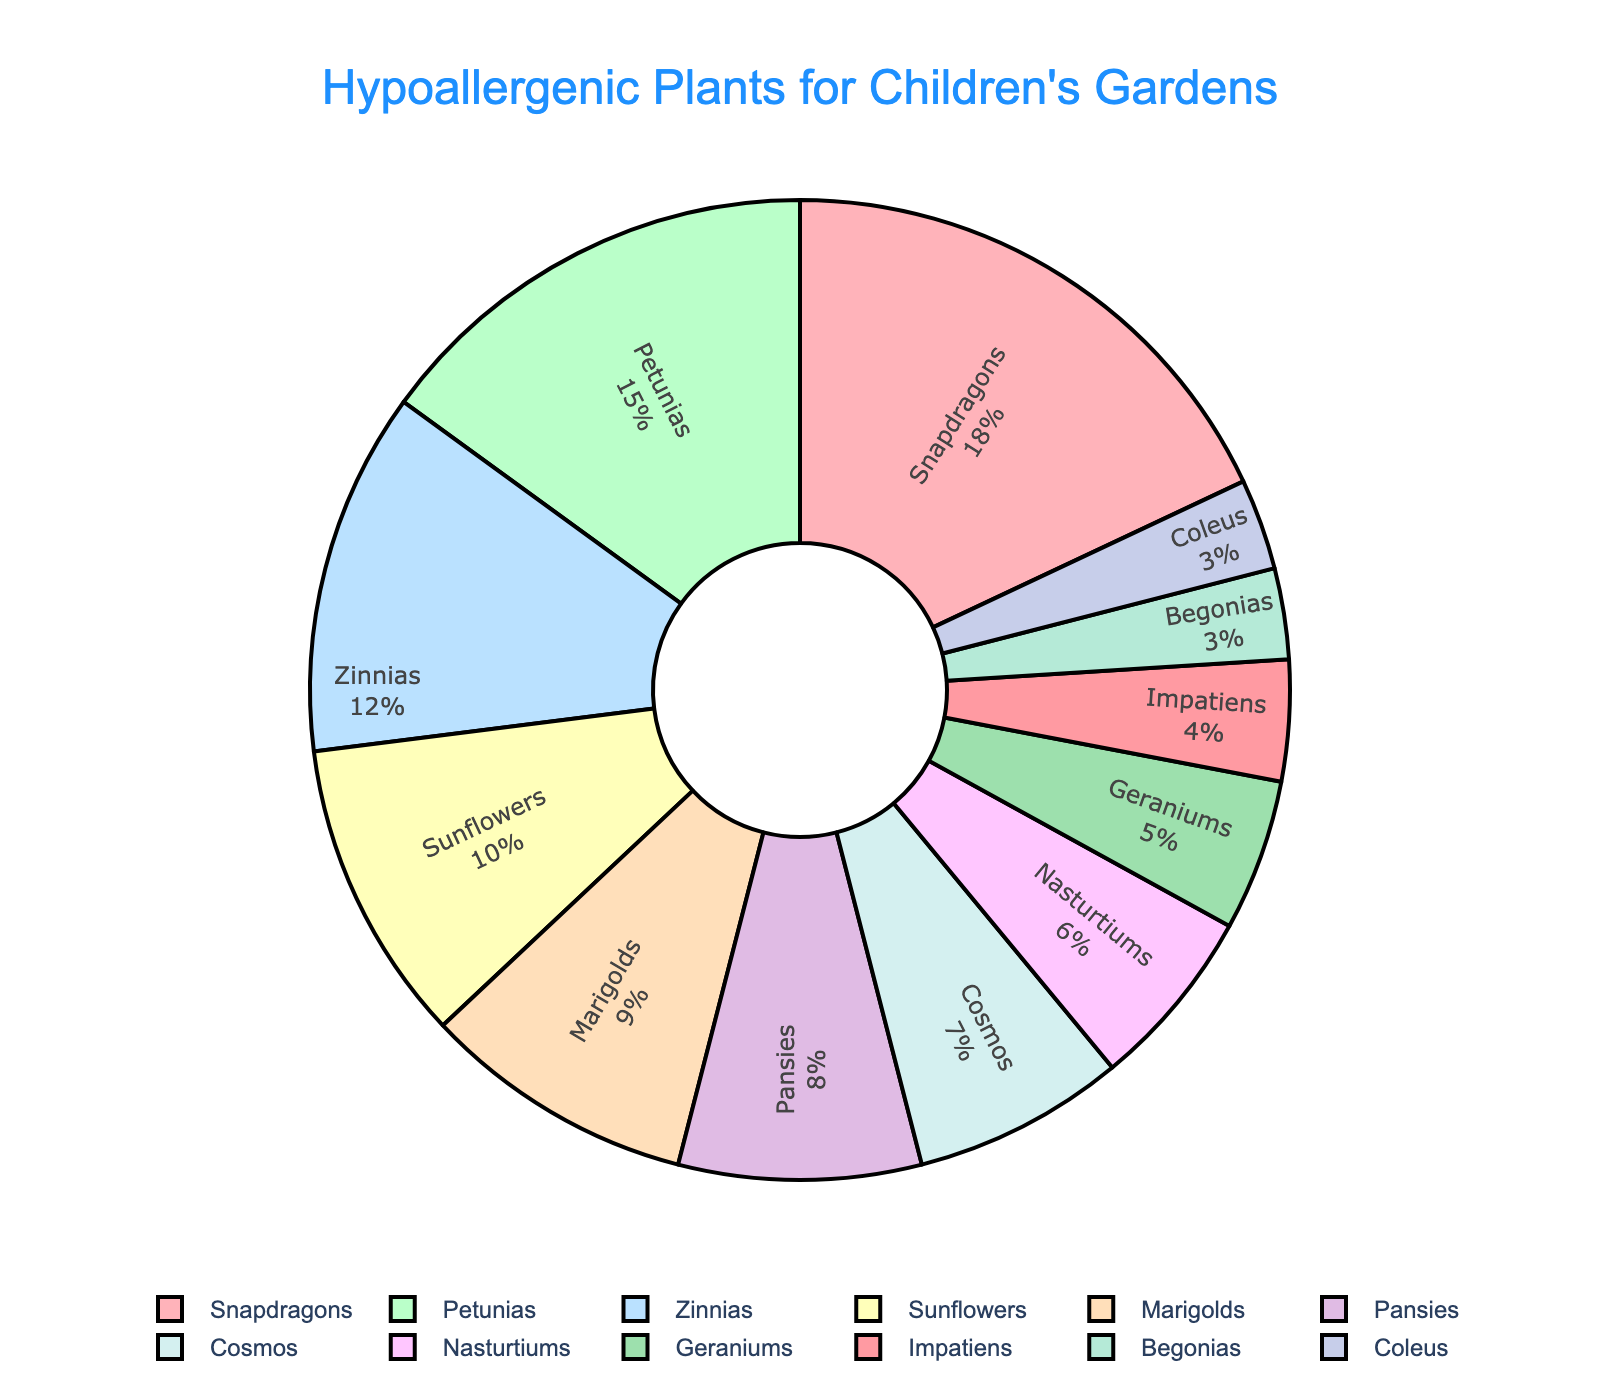What's the most common hypoallergenic plant in children's gardens? The most common plant is the one with the largest percentage slice in the pie chart. Snapdragons have the largest percentage slice, which is 18%.
Answer: Snapdragons What is the combined percentage of Zinnias and Sunflowers? Add the percentage values of Zinnias (12%) and Sunflowers (10%). Thus, the combined percentage is 12% + 10% = 22%.
Answer: 22% Which plant type is less common: Geraniums or Impatiens? Compare the percentage values: Geraniums (5%) and Impatiens (4%). Since 4% is less than 5%, Impatiens is less common.
Answer: Impatiens What is the total percentage of plants that have a percentage of 8% or higher? Sum the percentages of plants that are 8% or higher: Snapdragons (18%), Petunias (15%), Zinnias (12%), and Sunflowers (10%) and Pansies (8%). 18% + 15% + 12% + 10% + 8% = 63%.
Answer: 63% Which plant types have the smallest representation, and what is their combined percentage? Identify the plant types with the smallest percentages: Begonias (3%) and Coleus (3%). Add their percentages together: 3% + 3% = 6%.
Answer: Begonias and Coleus, 6% What is the visual color of the section for Marigolds? Marigolds are represented with a specific color in the pie chart to distinguish them visually. They are shown in orange.
Answer: Orange Are there more Nasturtiums or Cosmos in the garden, and by how much? Compare their percentages: Nasturtiums (6%) and Cosmos (7%). There are more Cosmos, and the difference is 7% - 6% = 1%.
Answer: Cosmos, by 1% What's the cumulative percentage of the bottom three plant types by percentage? Identify the bottom three (smallest percentages): Begonias (3%), Coleus (3%), and Impatiens (4%). Sum their percentages: 3% + 3% + 4% = 10%.
Answer: 10% What is the percentage difference between Snapdragons and Petunias? Subtract the percentage of Petunias from Snapdragons: 18% - 15% = 3%.
Answer: 3% Which plant type has the same color as the text for the title "Hypoallergenic Plants for Children's Gardens"? The title text is in blue. The plant type represented with the same color (or similar visual) would be Cosmos, shown in a shade of blue.
Answer: Cosmos 